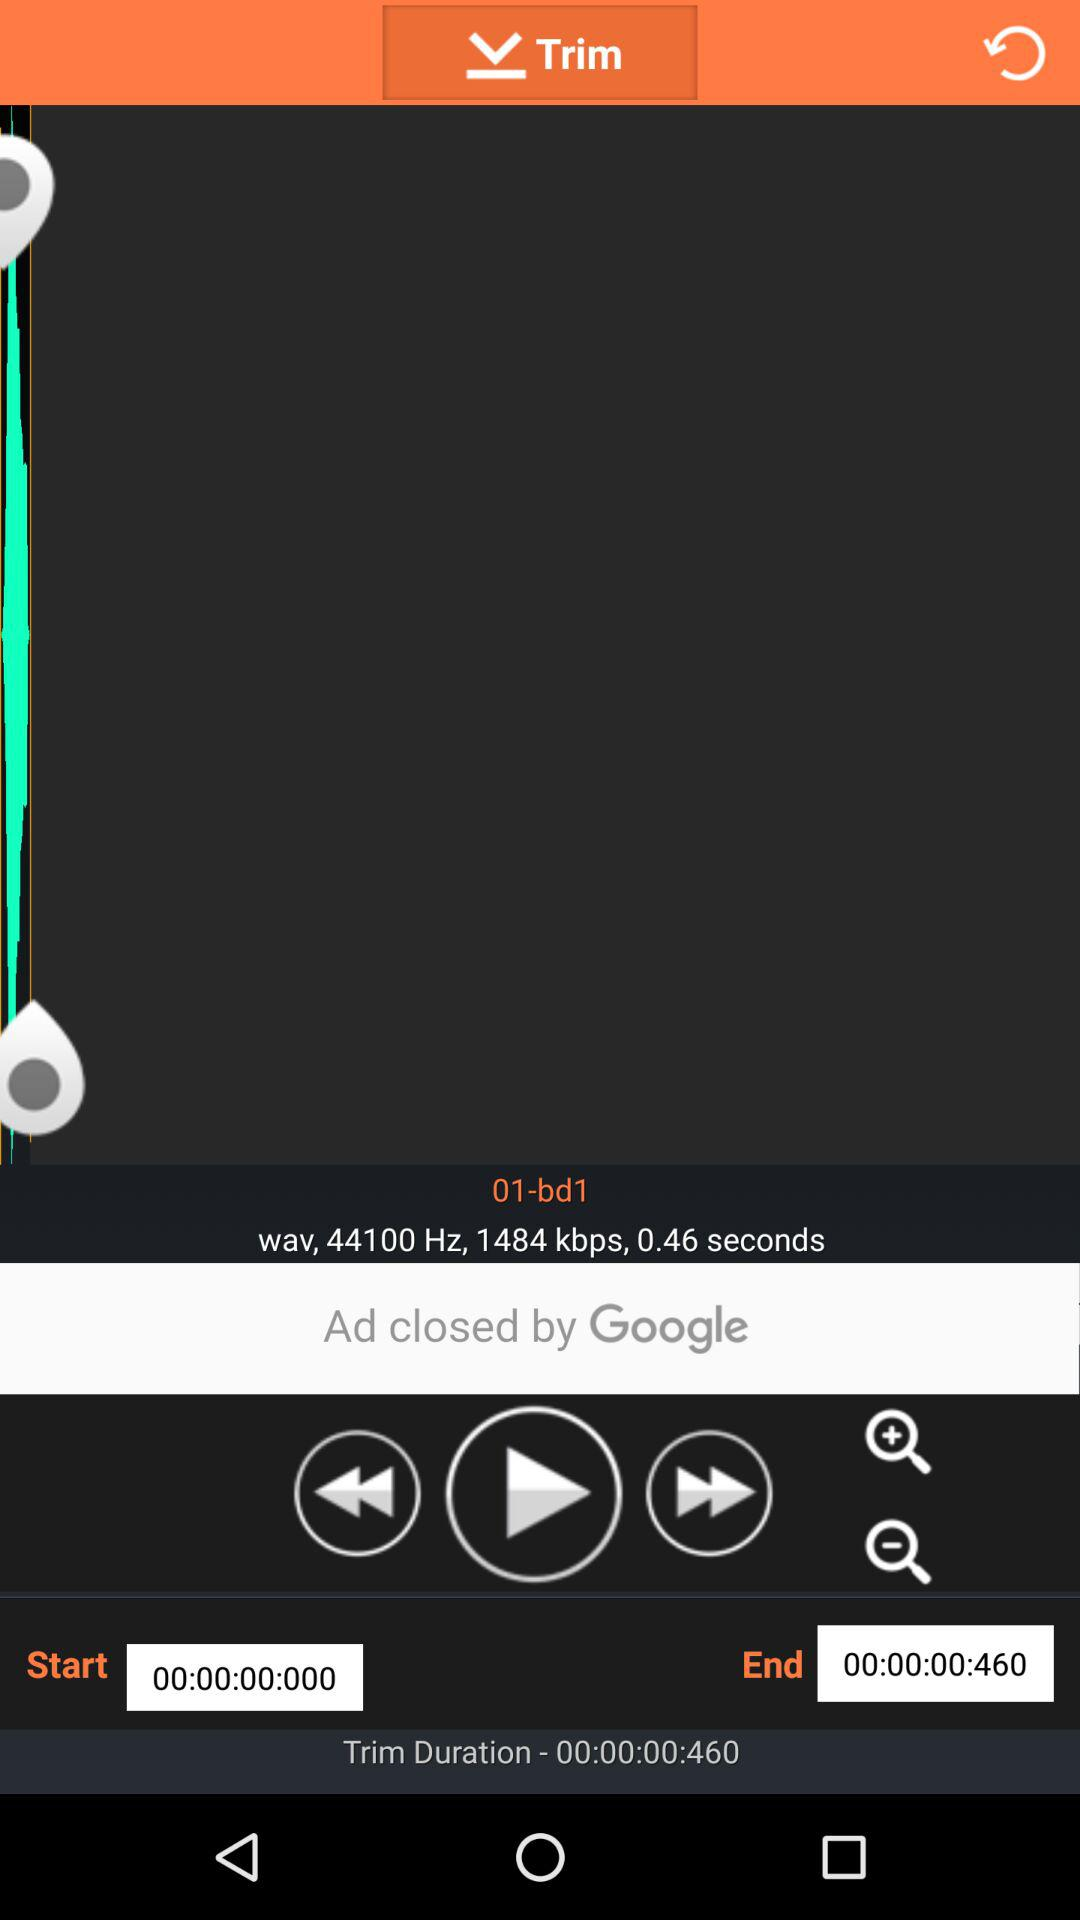What is the trim duration? The trim duration is "00:00:00:460". 